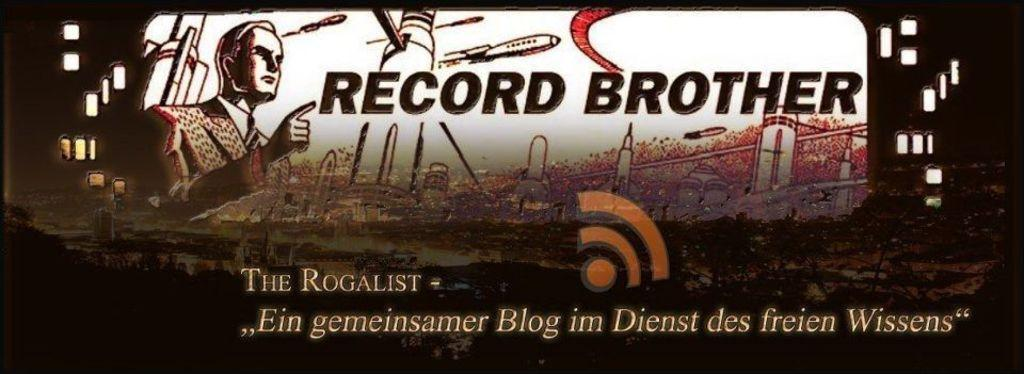Provide a one-sentence caption for the provided image. Looks to be a propaganda poster that says Record Brother. 